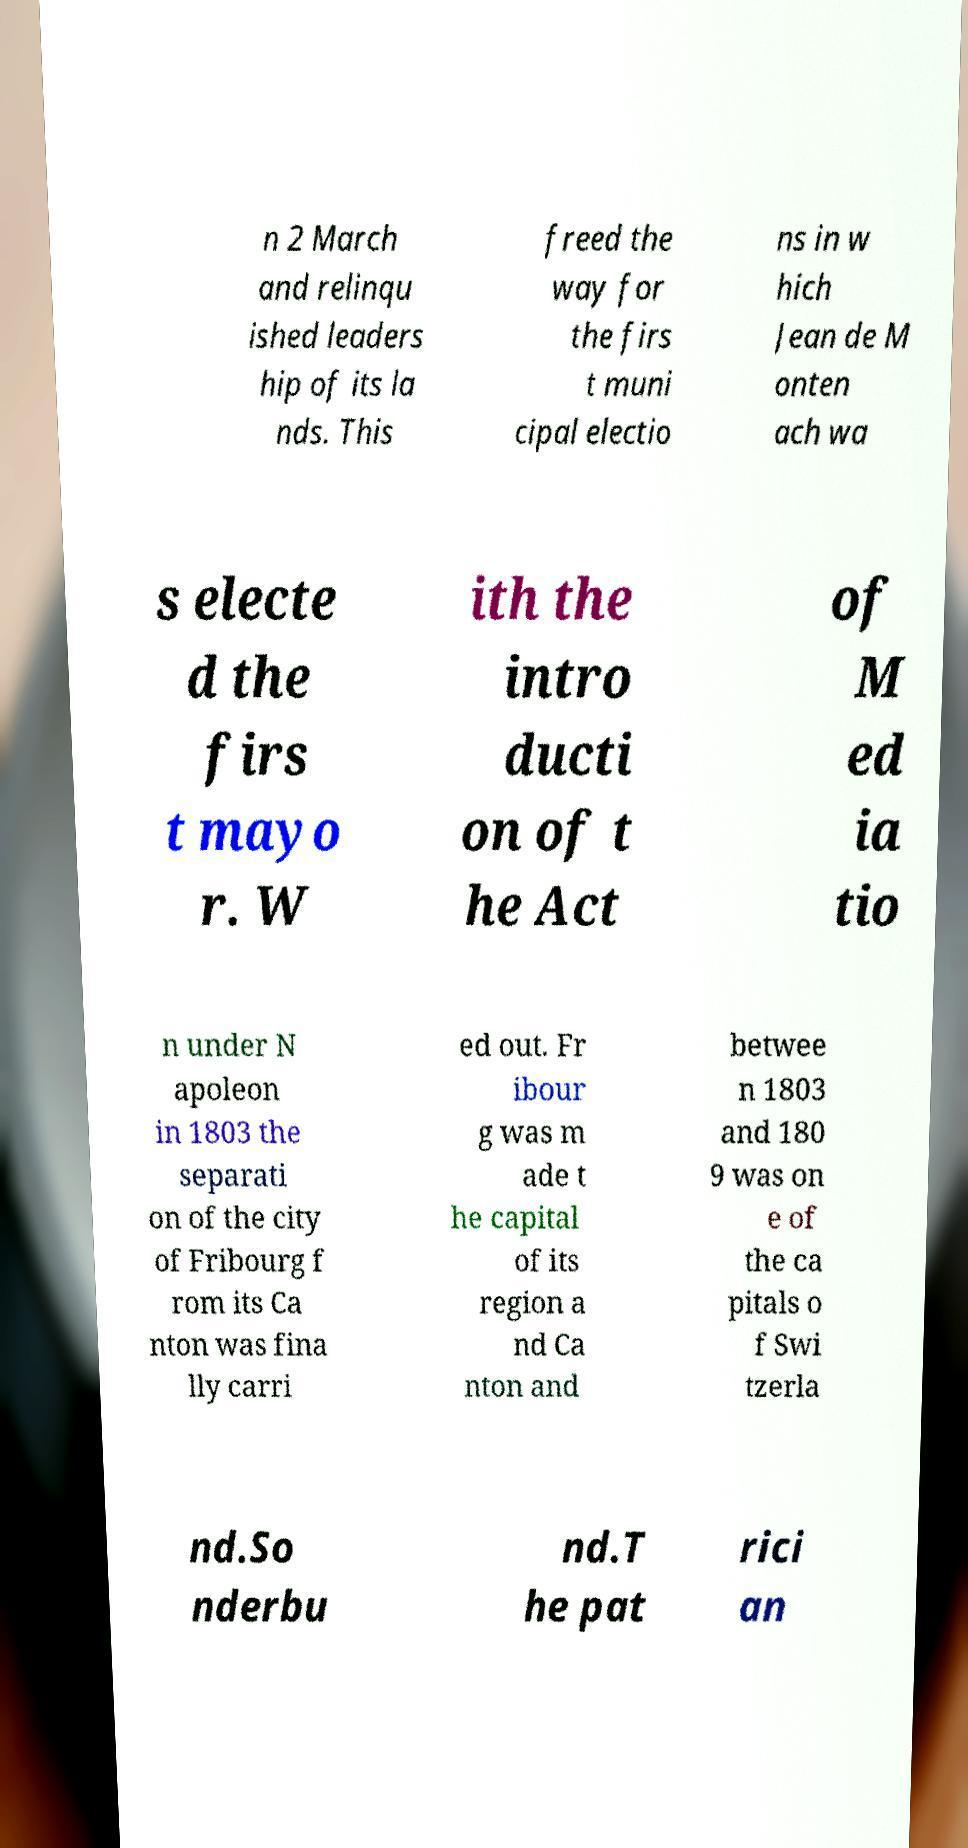There's text embedded in this image that I need extracted. Can you transcribe it verbatim? n 2 March and relinqu ished leaders hip of its la nds. This freed the way for the firs t muni cipal electio ns in w hich Jean de M onten ach wa s electe d the firs t mayo r. W ith the intro ducti on of t he Act of M ed ia tio n under N apoleon in 1803 the separati on of the city of Fribourg f rom its Ca nton was fina lly carri ed out. Fr ibour g was m ade t he capital of its region a nd Ca nton and betwee n 1803 and 180 9 was on e of the ca pitals o f Swi tzerla nd.So nderbu nd.T he pat rici an 